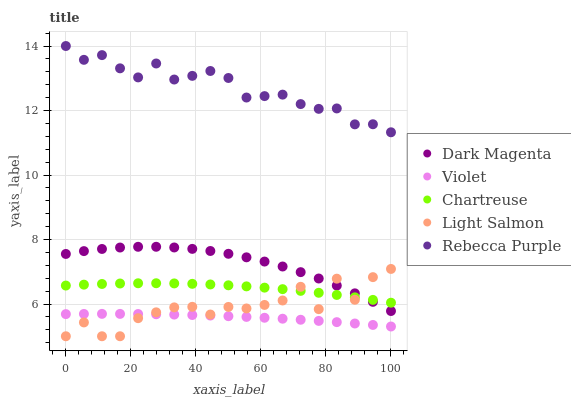Does Violet have the minimum area under the curve?
Answer yes or no. Yes. Does Rebecca Purple have the maximum area under the curve?
Answer yes or no. Yes. Does Light Salmon have the minimum area under the curve?
Answer yes or no. No. Does Light Salmon have the maximum area under the curve?
Answer yes or no. No. Is Violet the smoothest?
Answer yes or no. Yes. Is Light Salmon the roughest?
Answer yes or no. Yes. Is Dark Magenta the smoothest?
Answer yes or no. No. Is Dark Magenta the roughest?
Answer yes or no. No. Does Light Salmon have the lowest value?
Answer yes or no. Yes. Does Dark Magenta have the lowest value?
Answer yes or no. No. Does Rebecca Purple have the highest value?
Answer yes or no. Yes. Does Light Salmon have the highest value?
Answer yes or no. No. Is Violet less than Rebecca Purple?
Answer yes or no. Yes. Is Chartreuse greater than Violet?
Answer yes or no. Yes. Does Chartreuse intersect Dark Magenta?
Answer yes or no. Yes. Is Chartreuse less than Dark Magenta?
Answer yes or no. No. Is Chartreuse greater than Dark Magenta?
Answer yes or no. No. Does Violet intersect Rebecca Purple?
Answer yes or no. No. 